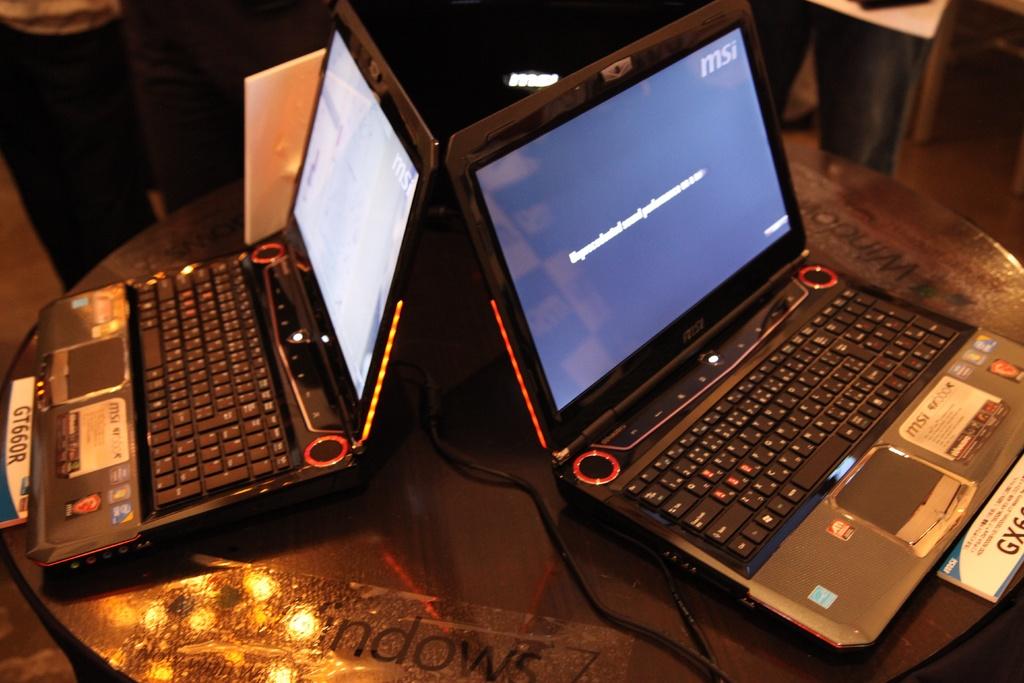What brand is seen on the right monitor?
Keep it short and to the point. Msi. What operating system is being advertised?
Provide a succinct answer. Windows. 